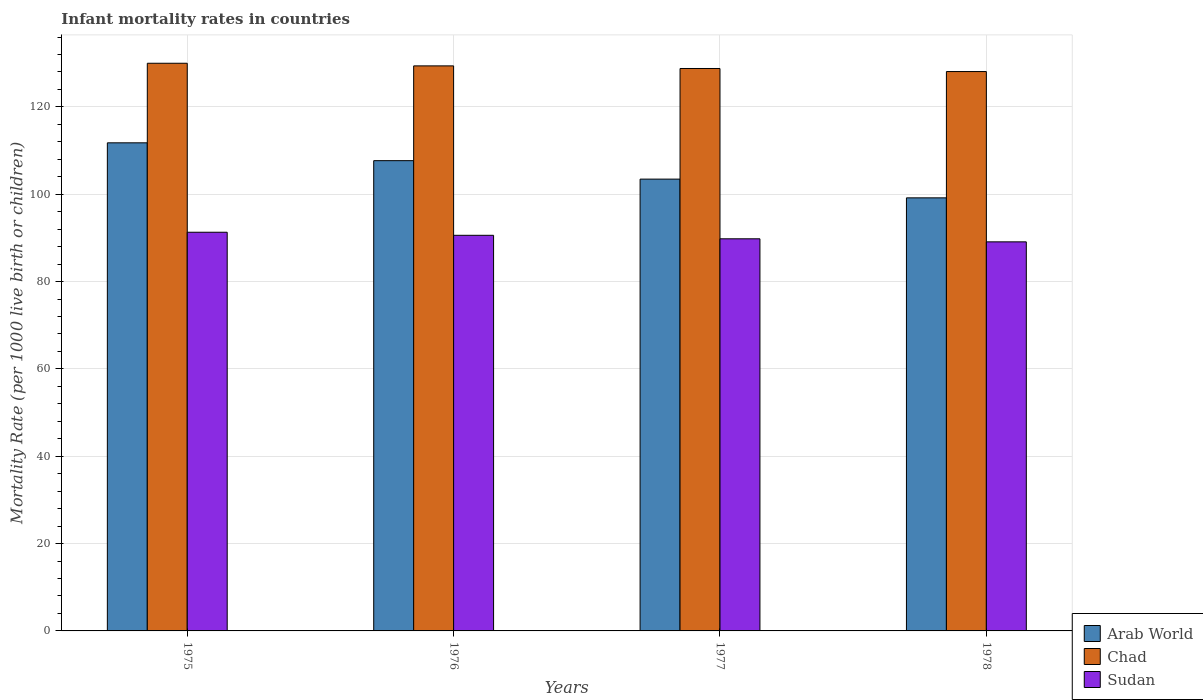How many different coloured bars are there?
Give a very brief answer. 3. How many groups of bars are there?
Give a very brief answer. 4. Are the number of bars per tick equal to the number of legend labels?
Provide a succinct answer. Yes. Are the number of bars on each tick of the X-axis equal?
Your response must be concise. Yes. How many bars are there on the 1st tick from the left?
Your response must be concise. 3. How many bars are there on the 2nd tick from the right?
Your answer should be very brief. 3. In how many cases, is the number of bars for a given year not equal to the number of legend labels?
Give a very brief answer. 0. What is the infant mortality rate in Arab World in 1977?
Your response must be concise. 103.47. Across all years, what is the maximum infant mortality rate in Chad?
Your answer should be compact. 130. Across all years, what is the minimum infant mortality rate in Sudan?
Provide a succinct answer. 89.1. In which year was the infant mortality rate in Sudan maximum?
Ensure brevity in your answer.  1975. In which year was the infant mortality rate in Sudan minimum?
Offer a very short reply. 1978. What is the total infant mortality rate in Chad in the graph?
Offer a very short reply. 516.3. What is the difference between the infant mortality rate in Arab World in 1975 and that in 1976?
Give a very brief answer. 4.09. What is the difference between the infant mortality rate in Sudan in 1976 and the infant mortality rate in Arab World in 1978?
Your answer should be very brief. -8.58. What is the average infant mortality rate in Sudan per year?
Give a very brief answer. 90.2. In the year 1976, what is the difference between the infant mortality rate in Chad and infant mortality rate in Arab World?
Make the answer very short. 21.71. What is the ratio of the infant mortality rate in Arab World in 1975 to that in 1976?
Offer a terse response. 1.04. Is the infant mortality rate in Arab World in 1975 less than that in 1978?
Your answer should be compact. No. What is the difference between the highest and the second highest infant mortality rate in Chad?
Your answer should be very brief. 0.6. What is the difference between the highest and the lowest infant mortality rate in Sudan?
Ensure brevity in your answer.  2.2. In how many years, is the infant mortality rate in Chad greater than the average infant mortality rate in Chad taken over all years?
Make the answer very short. 2. Is the sum of the infant mortality rate in Chad in 1976 and 1978 greater than the maximum infant mortality rate in Arab World across all years?
Ensure brevity in your answer.  Yes. What does the 3rd bar from the left in 1976 represents?
Offer a terse response. Sudan. What does the 1st bar from the right in 1975 represents?
Provide a short and direct response. Sudan. Is it the case that in every year, the sum of the infant mortality rate in Arab World and infant mortality rate in Chad is greater than the infant mortality rate in Sudan?
Ensure brevity in your answer.  Yes. What is the difference between two consecutive major ticks on the Y-axis?
Give a very brief answer. 20. Are the values on the major ticks of Y-axis written in scientific E-notation?
Ensure brevity in your answer.  No. Does the graph contain any zero values?
Offer a very short reply. No. How many legend labels are there?
Your answer should be compact. 3. What is the title of the graph?
Your answer should be very brief. Infant mortality rates in countries. Does "Least developed countries" appear as one of the legend labels in the graph?
Provide a short and direct response. No. What is the label or title of the X-axis?
Offer a terse response. Years. What is the label or title of the Y-axis?
Give a very brief answer. Mortality Rate (per 1000 live birth or children). What is the Mortality Rate (per 1000 live birth or children) in Arab World in 1975?
Provide a succinct answer. 111.78. What is the Mortality Rate (per 1000 live birth or children) of Chad in 1975?
Provide a short and direct response. 130. What is the Mortality Rate (per 1000 live birth or children) of Sudan in 1975?
Keep it short and to the point. 91.3. What is the Mortality Rate (per 1000 live birth or children) of Arab World in 1976?
Offer a very short reply. 107.69. What is the Mortality Rate (per 1000 live birth or children) of Chad in 1976?
Your response must be concise. 129.4. What is the Mortality Rate (per 1000 live birth or children) in Sudan in 1976?
Keep it short and to the point. 90.6. What is the Mortality Rate (per 1000 live birth or children) of Arab World in 1977?
Your answer should be compact. 103.47. What is the Mortality Rate (per 1000 live birth or children) in Chad in 1977?
Ensure brevity in your answer.  128.8. What is the Mortality Rate (per 1000 live birth or children) in Sudan in 1977?
Offer a terse response. 89.8. What is the Mortality Rate (per 1000 live birth or children) of Arab World in 1978?
Offer a very short reply. 99.18. What is the Mortality Rate (per 1000 live birth or children) of Chad in 1978?
Give a very brief answer. 128.1. What is the Mortality Rate (per 1000 live birth or children) of Sudan in 1978?
Provide a succinct answer. 89.1. Across all years, what is the maximum Mortality Rate (per 1000 live birth or children) in Arab World?
Give a very brief answer. 111.78. Across all years, what is the maximum Mortality Rate (per 1000 live birth or children) of Chad?
Make the answer very short. 130. Across all years, what is the maximum Mortality Rate (per 1000 live birth or children) in Sudan?
Ensure brevity in your answer.  91.3. Across all years, what is the minimum Mortality Rate (per 1000 live birth or children) of Arab World?
Offer a terse response. 99.18. Across all years, what is the minimum Mortality Rate (per 1000 live birth or children) of Chad?
Your answer should be compact. 128.1. Across all years, what is the minimum Mortality Rate (per 1000 live birth or children) in Sudan?
Ensure brevity in your answer.  89.1. What is the total Mortality Rate (per 1000 live birth or children) in Arab World in the graph?
Provide a short and direct response. 422.12. What is the total Mortality Rate (per 1000 live birth or children) in Chad in the graph?
Make the answer very short. 516.3. What is the total Mortality Rate (per 1000 live birth or children) of Sudan in the graph?
Keep it short and to the point. 360.8. What is the difference between the Mortality Rate (per 1000 live birth or children) in Arab World in 1975 and that in 1976?
Your answer should be compact. 4.09. What is the difference between the Mortality Rate (per 1000 live birth or children) in Arab World in 1975 and that in 1977?
Make the answer very short. 8.31. What is the difference between the Mortality Rate (per 1000 live birth or children) in Chad in 1975 and that in 1977?
Provide a short and direct response. 1.2. What is the difference between the Mortality Rate (per 1000 live birth or children) in Sudan in 1975 and that in 1977?
Make the answer very short. 1.5. What is the difference between the Mortality Rate (per 1000 live birth or children) of Arab World in 1975 and that in 1978?
Provide a succinct answer. 12.6. What is the difference between the Mortality Rate (per 1000 live birth or children) of Chad in 1975 and that in 1978?
Keep it short and to the point. 1.9. What is the difference between the Mortality Rate (per 1000 live birth or children) of Arab World in 1976 and that in 1977?
Keep it short and to the point. 4.23. What is the difference between the Mortality Rate (per 1000 live birth or children) in Chad in 1976 and that in 1977?
Provide a succinct answer. 0.6. What is the difference between the Mortality Rate (per 1000 live birth or children) in Arab World in 1976 and that in 1978?
Your response must be concise. 8.51. What is the difference between the Mortality Rate (per 1000 live birth or children) in Sudan in 1976 and that in 1978?
Your response must be concise. 1.5. What is the difference between the Mortality Rate (per 1000 live birth or children) of Arab World in 1977 and that in 1978?
Your answer should be very brief. 4.29. What is the difference between the Mortality Rate (per 1000 live birth or children) of Sudan in 1977 and that in 1978?
Provide a succinct answer. 0.7. What is the difference between the Mortality Rate (per 1000 live birth or children) of Arab World in 1975 and the Mortality Rate (per 1000 live birth or children) of Chad in 1976?
Your response must be concise. -17.62. What is the difference between the Mortality Rate (per 1000 live birth or children) of Arab World in 1975 and the Mortality Rate (per 1000 live birth or children) of Sudan in 1976?
Make the answer very short. 21.18. What is the difference between the Mortality Rate (per 1000 live birth or children) in Chad in 1975 and the Mortality Rate (per 1000 live birth or children) in Sudan in 1976?
Offer a very short reply. 39.4. What is the difference between the Mortality Rate (per 1000 live birth or children) in Arab World in 1975 and the Mortality Rate (per 1000 live birth or children) in Chad in 1977?
Your response must be concise. -17.02. What is the difference between the Mortality Rate (per 1000 live birth or children) in Arab World in 1975 and the Mortality Rate (per 1000 live birth or children) in Sudan in 1977?
Give a very brief answer. 21.98. What is the difference between the Mortality Rate (per 1000 live birth or children) of Chad in 1975 and the Mortality Rate (per 1000 live birth or children) of Sudan in 1977?
Your response must be concise. 40.2. What is the difference between the Mortality Rate (per 1000 live birth or children) in Arab World in 1975 and the Mortality Rate (per 1000 live birth or children) in Chad in 1978?
Offer a very short reply. -16.32. What is the difference between the Mortality Rate (per 1000 live birth or children) in Arab World in 1975 and the Mortality Rate (per 1000 live birth or children) in Sudan in 1978?
Give a very brief answer. 22.68. What is the difference between the Mortality Rate (per 1000 live birth or children) of Chad in 1975 and the Mortality Rate (per 1000 live birth or children) of Sudan in 1978?
Ensure brevity in your answer.  40.9. What is the difference between the Mortality Rate (per 1000 live birth or children) of Arab World in 1976 and the Mortality Rate (per 1000 live birth or children) of Chad in 1977?
Your answer should be compact. -21.11. What is the difference between the Mortality Rate (per 1000 live birth or children) of Arab World in 1976 and the Mortality Rate (per 1000 live birth or children) of Sudan in 1977?
Offer a very short reply. 17.89. What is the difference between the Mortality Rate (per 1000 live birth or children) of Chad in 1976 and the Mortality Rate (per 1000 live birth or children) of Sudan in 1977?
Offer a very short reply. 39.6. What is the difference between the Mortality Rate (per 1000 live birth or children) of Arab World in 1976 and the Mortality Rate (per 1000 live birth or children) of Chad in 1978?
Your answer should be very brief. -20.41. What is the difference between the Mortality Rate (per 1000 live birth or children) in Arab World in 1976 and the Mortality Rate (per 1000 live birth or children) in Sudan in 1978?
Keep it short and to the point. 18.59. What is the difference between the Mortality Rate (per 1000 live birth or children) of Chad in 1976 and the Mortality Rate (per 1000 live birth or children) of Sudan in 1978?
Make the answer very short. 40.3. What is the difference between the Mortality Rate (per 1000 live birth or children) in Arab World in 1977 and the Mortality Rate (per 1000 live birth or children) in Chad in 1978?
Your answer should be compact. -24.63. What is the difference between the Mortality Rate (per 1000 live birth or children) in Arab World in 1977 and the Mortality Rate (per 1000 live birth or children) in Sudan in 1978?
Keep it short and to the point. 14.37. What is the difference between the Mortality Rate (per 1000 live birth or children) in Chad in 1977 and the Mortality Rate (per 1000 live birth or children) in Sudan in 1978?
Offer a very short reply. 39.7. What is the average Mortality Rate (per 1000 live birth or children) in Arab World per year?
Make the answer very short. 105.53. What is the average Mortality Rate (per 1000 live birth or children) in Chad per year?
Provide a short and direct response. 129.07. What is the average Mortality Rate (per 1000 live birth or children) of Sudan per year?
Keep it short and to the point. 90.2. In the year 1975, what is the difference between the Mortality Rate (per 1000 live birth or children) in Arab World and Mortality Rate (per 1000 live birth or children) in Chad?
Keep it short and to the point. -18.22. In the year 1975, what is the difference between the Mortality Rate (per 1000 live birth or children) in Arab World and Mortality Rate (per 1000 live birth or children) in Sudan?
Your answer should be very brief. 20.48. In the year 1975, what is the difference between the Mortality Rate (per 1000 live birth or children) of Chad and Mortality Rate (per 1000 live birth or children) of Sudan?
Make the answer very short. 38.7. In the year 1976, what is the difference between the Mortality Rate (per 1000 live birth or children) in Arab World and Mortality Rate (per 1000 live birth or children) in Chad?
Your answer should be compact. -21.71. In the year 1976, what is the difference between the Mortality Rate (per 1000 live birth or children) in Arab World and Mortality Rate (per 1000 live birth or children) in Sudan?
Offer a very short reply. 17.09. In the year 1976, what is the difference between the Mortality Rate (per 1000 live birth or children) in Chad and Mortality Rate (per 1000 live birth or children) in Sudan?
Ensure brevity in your answer.  38.8. In the year 1977, what is the difference between the Mortality Rate (per 1000 live birth or children) in Arab World and Mortality Rate (per 1000 live birth or children) in Chad?
Provide a succinct answer. -25.33. In the year 1977, what is the difference between the Mortality Rate (per 1000 live birth or children) of Arab World and Mortality Rate (per 1000 live birth or children) of Sudan?
Make the answer very short. 13.67. In the year 1977, what is the difference between the Mortality Rate (per 1000 live birth or children) in Chad and Mortality Rate (per 1000 live birth or children) in Sudan?
Provide a short and direct response. 39. In the year 1978, what is the difference between the Mortality Rate (per 1000 live birth or children) of Arab World and Mortality Rate (per 1000 live birth or children) of Chad?
Your answer should be compact. -28.92. In the year 1978, what is the difference between the Mortality Rate (per 1000 live birth or children) of Arab World and Mortality Rate (per 1000 live birth or children) of Sudan?
Give a very brief answer. 10.08. What is the ratio of the Mortality Rate (per 1000 live birth or children) in Arab World in 1975 to that in 1976?
Ensure brevity in your answer.  1.04. What is the ratio of the Mortality Rate (per 1000 live birth or children) in Chad in 1975 to that in 1976?
Provide a short and direct response. 1. What is the ratio of the Mortality Rate (per 1000 live birth or children) of Sudan in 1975 to that in 1976?
Offer a very short reply. 1.01. What is the ratio of the Mortality Rate (per 1000 live birth or children) in Arab World in 1975 to that in 1977?
Give a very brief answer. 1.08. What is the ratio of the Mortality Rate (per 1000 live birth or children) in Chad in 1975 to that in 1977?
Offer a terse response. 1.01. What is the ratio of the Mortality Rate (per 1000 live birth or children) of Sudan in 1975 to that in 1977?
Provide a short and direct response. 1.02. What is the ratio of the Mortality Rate (per 1000 live birth or children) in Arab World in 1975 to that in 1978?
Your answer should be very brief. 1.13. What is the ratio of the Mortality Rate (per 1000 live birth or children) in Chad in 1975 to that in 1978?
Your response must be concise. 1.01. What is the ratio of the Mortality Rate (per 1000 live birth or children) of Sudan in 1975 to that in 1978?
Ensure brevity in your answer.  1.02. What is the ratio of the Mortality Rate (per 1000 live birth or children) of Arab World in 1976 to that in 1977?
Ensure brevity in your answer.  1.04. What is the ratio of the Mortality Rate (per 1000 live birth or children) in Chad in 1976 to that in 1977?
Your answer should be compact. 1. What is the ratio of the Mortality Rate (per 1000 live birth or children) of Sudan in 1976 to that in 1977?
Offer a very short reply. 1.01. What is the ratio of the Mortality Rate (per 1000 live birth or children) of Arab World in 1976 to that in 1978?
Provide a succinct answer. 1.09. What is the ratio of the Mortality Rate (per 1000 live birth or children) in Sudan in 1976 to that in 1978?
Provide a short and direct response. 1.02. What is the ratio of the Mortality Rate (per 1000 live birth or children) of Arab World in 1977 to that in 1978?
Offer a terse response. 1.04. What is the ratio of the Mortality Rate (per 1000 live birth or children) of Chad in 1977 to that in 1978?
Provide a short and direct response. 1.01. What is the ratio of the Mortality Rate (per 1000 live birth or children) in Sudan in 1977 to that in 1978?
Provide a succinct answer. 1.01. What is the difference between the highest and the second highest Mortality Rate (per 1000 live birth or children) of Arab World?
Make the answer very short. 4.09. What is the difference between the highest and the second highest Mortality Rate (per 1000 live birth or children) in Chad?
Ensure brevity in your answer.  0.6. What is the difference between the highest and the second highest Mortality Rate (per 1000 live birth or children) of Sudan?
Make the answer very short. 0.7. What is the difference between the highest and the lowest Mortality Rate (per 1000 live birth or children) in Arab World?
Provide a short and direct response. 12.6. What is the difference between the highest and the lowest Mortality Rate (per 1000 live birth or children) in Chad?
Make the answer very short. 1.9. 